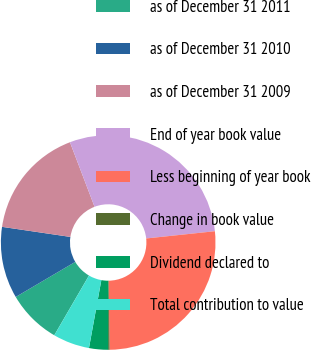Convert chart to OTSL. <chart><loc_0><loc_0><loc_500><loc_500><pie_chart><fcel>as of December 31 2011<fcel>as of December 31 2010<fcel>as of December 31 2009<fcel>End of year book value<fcel>Less beginning of year book<fcel>Change in book value<fcel>Dividend declared to<fcel>Total contribution to value<nl><fcel>8.15%<fcel>10.8%<fcel>16.87%<fcel>29.12%<fcel>26.47%<fcel>0.21%<fcel>2.86%<fcel>5.51%<nl></chart> 